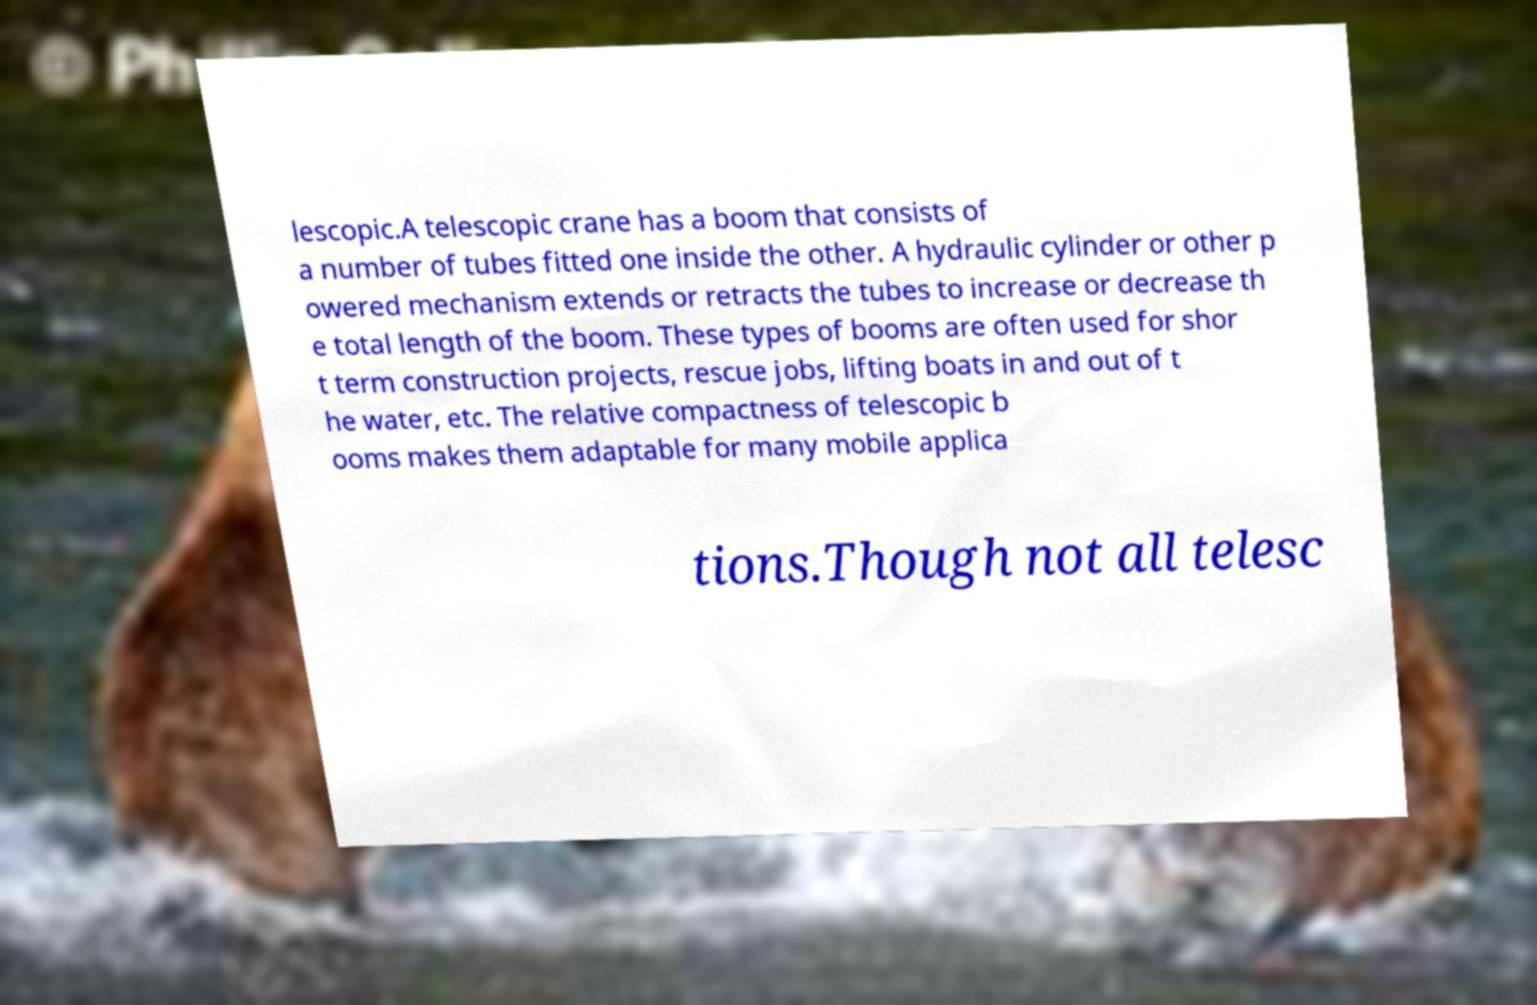There's text embedded in this image that I need extracted. Can you transcribe it verbatim? lescopic.A telescopic crane has a boom that consists of a number of tubes fitted one inside the other. A hydraulic cylinder or other p owered mechanism extends or retracts the tubes to increase or decrease th e total length of the boom. These types of booms are often used for shor t term construction projects, rescue jobs, lifting boats in and out of t he water, etc. The relative compactness of telescopic b ooms makes them adaptable for many mobile applica tions.Though not all telesc 